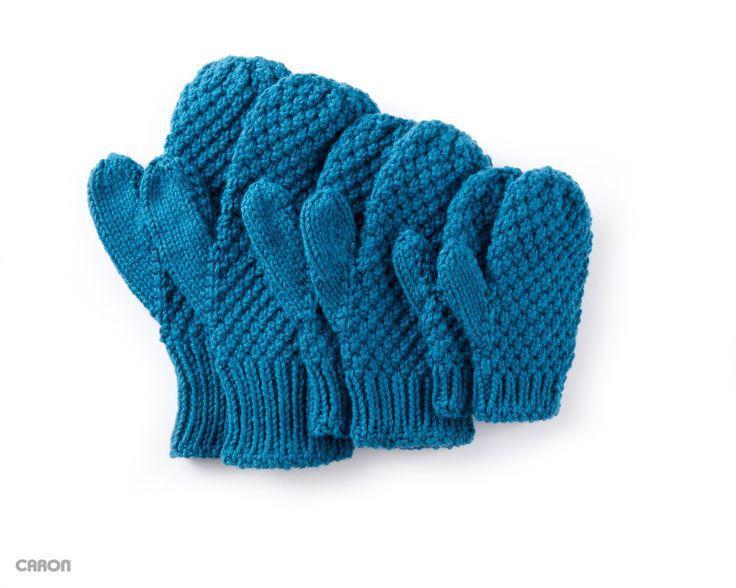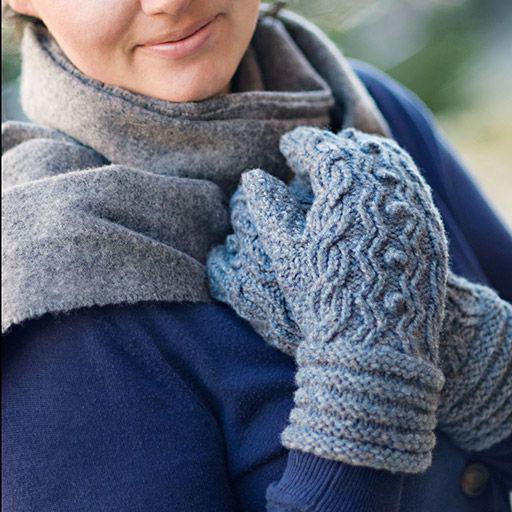The first image is the image on the left, the second image is the image on the right. Evaluate the accuracy of this statement regarding the images: "Solid color mittens appear in each image, a different color and pattern in each one, with one pair worn by a person.". Is it true? Answer yes or no. Yes. 